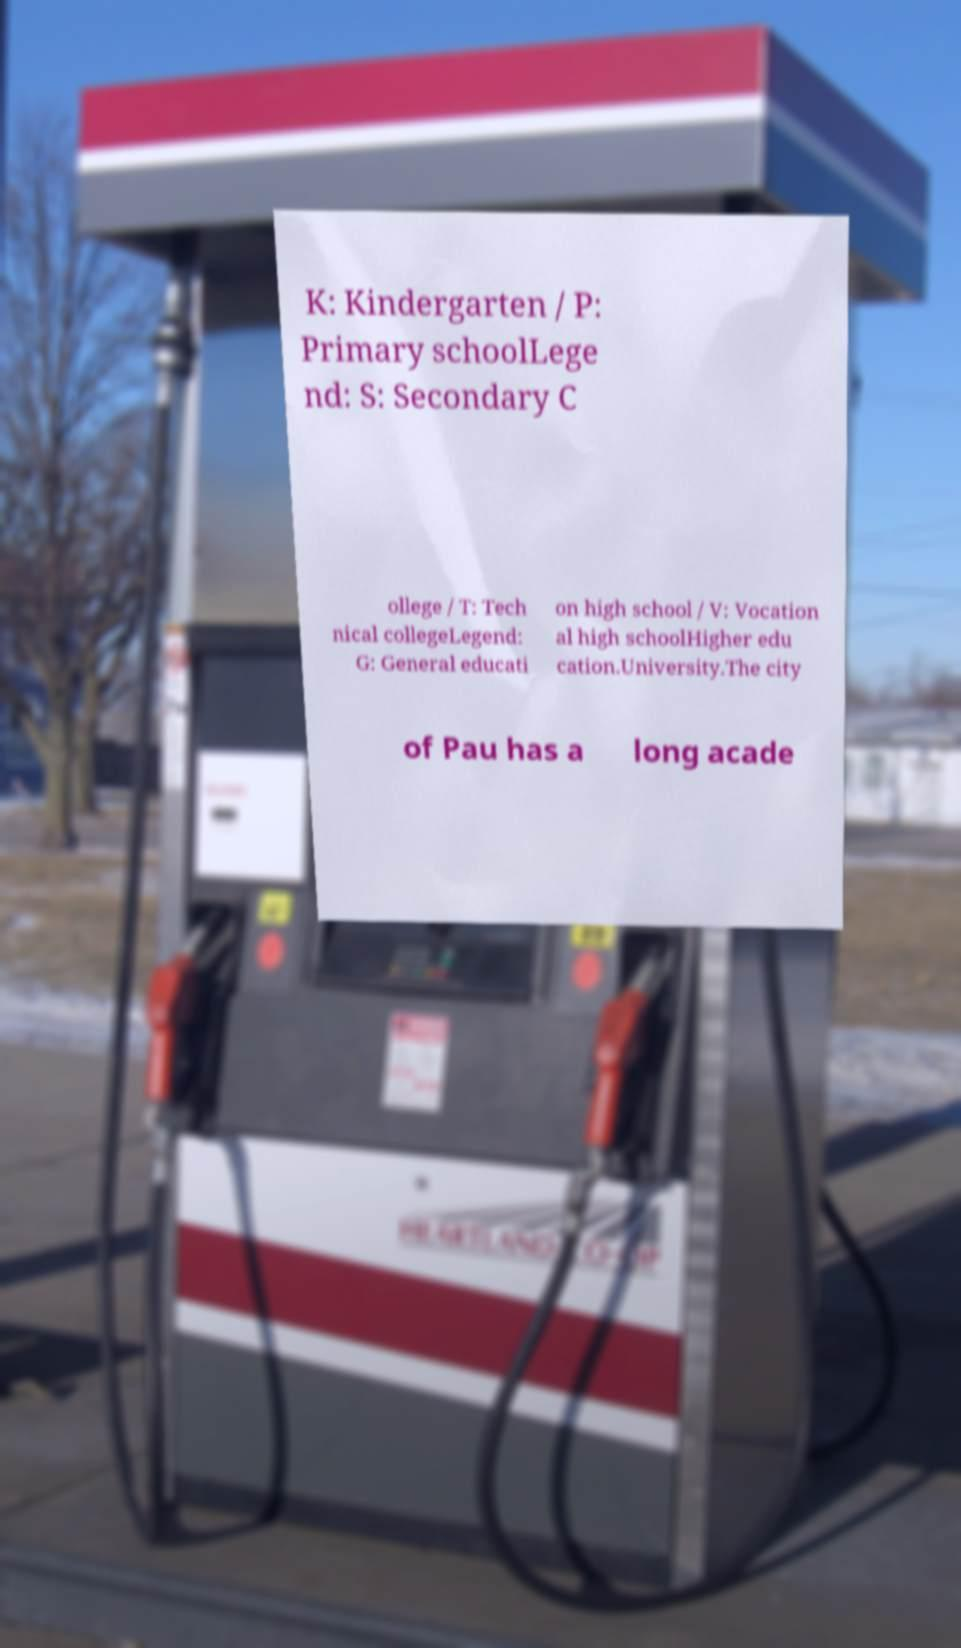There's text embedded in this image that I need extracted. Can you transcribe it verbatim? K: Kindergarten / P: Primary schoolLege nd: S: Secondary C ollege / T: Tech nical collegeLegend: G: General educati on high school / V: Vocation al high schoolHigher edu cation.University.The city of Pau has a long acade 